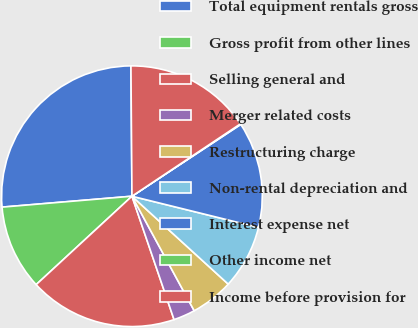Convert chart to OTSL. <chart><loc_0><loc_0><loc_500><loc_500><pie_chart><fcel>Total equipment rentals gross<fcel>Gross profit from other lines<fcel>Selling general and<fcel>Merger related costs<fcel>Restructuring charge<fcel>Non-rental depreciation and<fcel>Interest expense net<fcel>Other income net<fcel>Income before provision for<nl><fcel>26.21%<fcel>10.53%<fcel>18.37%<fcel>2.69%<fcel>5.3%<fcel>7.92%<fcel>13.14%<fcel>0.08%<fcel>15.76%<nl></chart> 